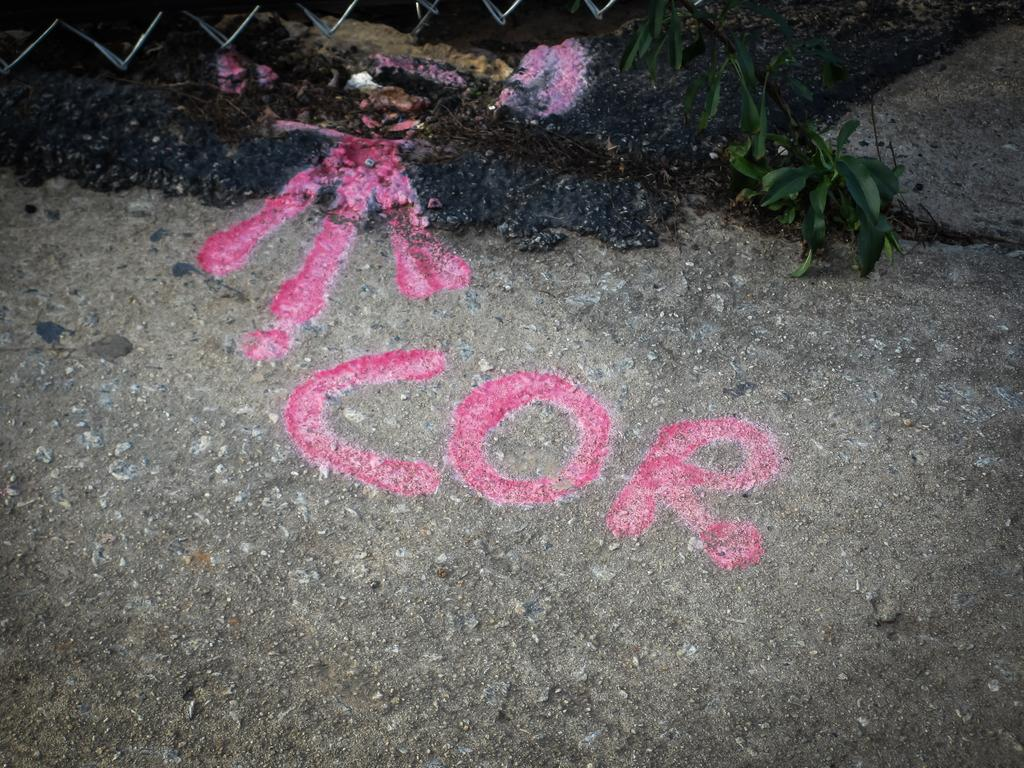What is located in the center of the image? There is a paint on the ground in the center of the image. What can be seen in the background of the image? There is a fence and a stem of a tree in the background of the image. What type of apparel is the ocean wearing in the image? There is no ocean present in the image, and therefore no apparel can be associated with it. 